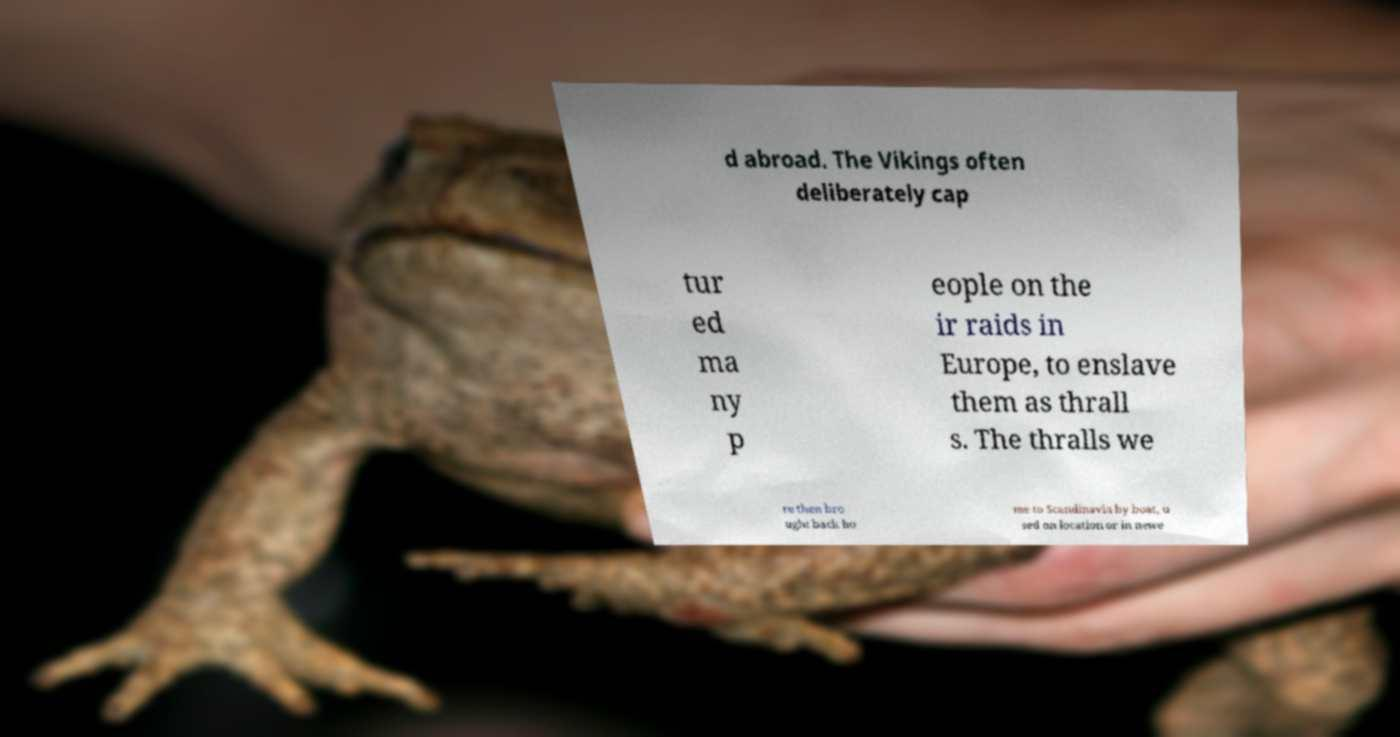Please read and relay the text visible in this image. What does it say? d abroad. The Vikings often deliberately cap tur ed ma ny p eople on the ir raids in Europe, to enslave them as thrall s. The thralls we re then bro ught back ho me to Scandinavia by boat, u sed on location or in newe 